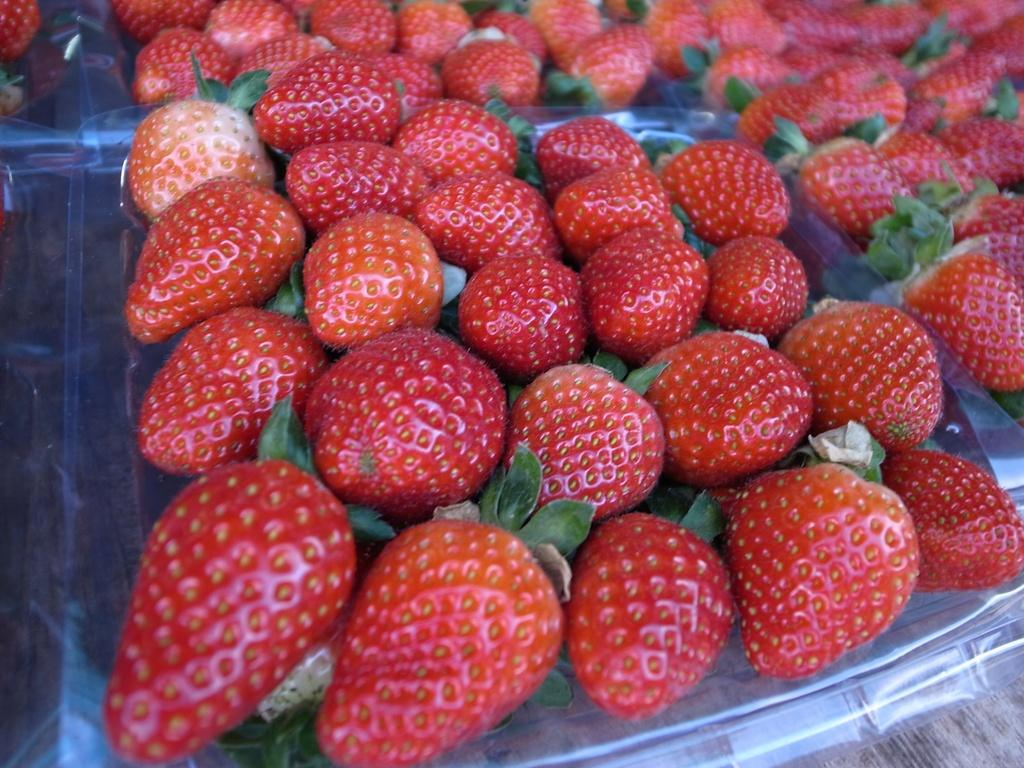What type of fruit is present in the image? There are strawberries in the image. What is the color of the strawberries? The strawberries are red in color. What else is visible in the image besides the strawberries? There are green leaves in the image. Where are the strawberries and leaves located? The strawberries and leaves are on a plastic cover. What type of wood is used to make the jail in the image? There is no jail present in the image, so it is not possible to determine what type of wood might be used. 